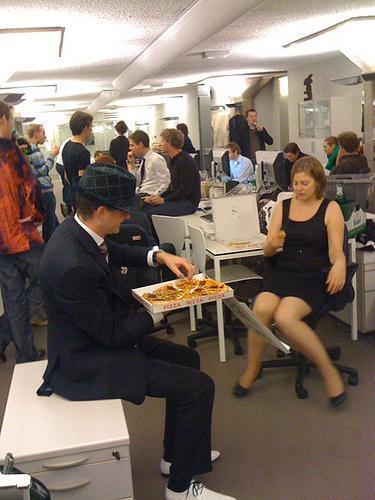Where are people here eating pizza today?
Indicate the correct response and explain using: 'Answer: answer
Rationale: rationale.'
Options: Icecream shop, pizzeria, office setting, malt shop. Answer: office setting.
Rationale: The people are in the office. 